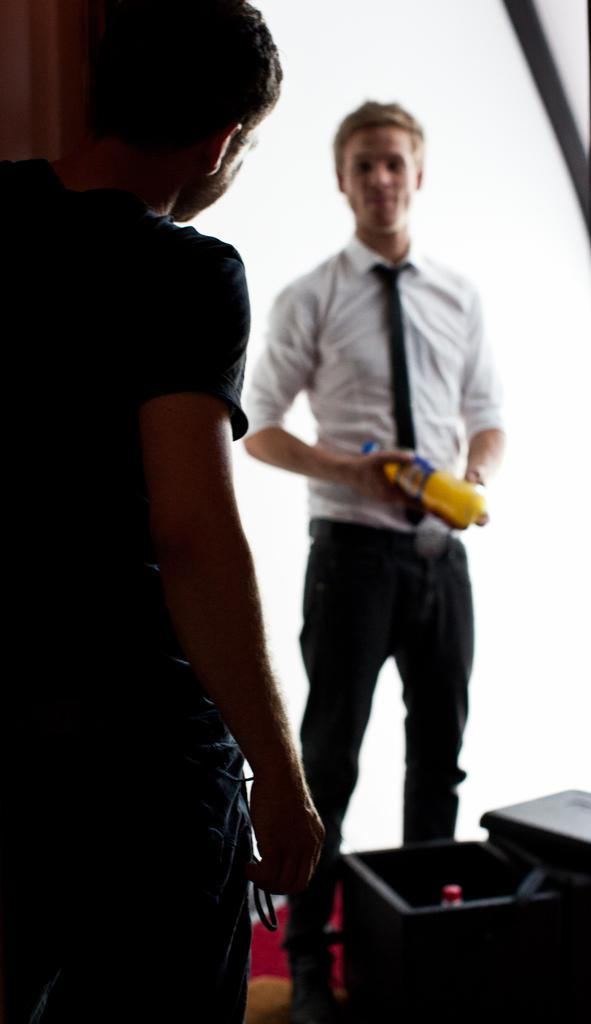Who is the person standing on the left side of the image? There is a man standing on the left side of the image. What is the boy in the middle of the image doing? The boy is holding a bottle in his hands. What color is the shirt the boy is wearing? The boy is wearing a white color shirt. What color are the trousers the boy is wearing? The boy is wearing black color trousers. What type of music is the boy playing in the image? There is no music or musical instrument present in the image. 